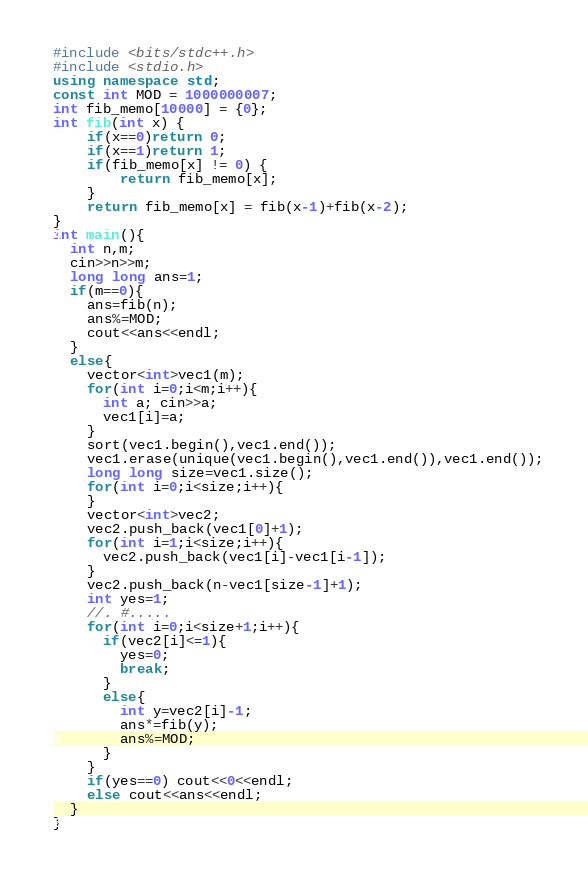<code> <loc_0><loc_0><loc_500><loc_500><_C++_>#include <bits/stdc++.h>
#include <stdio.h>
using namespace std;
const int MOD = 1000000007;
int fib_memo[10000] = {0};
int fib(int x) {
    if(x==0)return 0;
    if(x==1)return 1;
    if(fib_memo[x] != 0) {
        return fib_memo[x];
    }
    return fib_memo[x] = fib(x-1)+fib(x-2);
}
int main(){
  int n,m;  
  cin>>n>>m;
  long long ans=1;
  if(m==0){
    ans=fib(n);
    ans%=MOD;
    cout<<ans<<endl;
  }
  else{
    vector<int>vec1(m);
    for(int i=0;i<m;i++){
      int a; cin>>a;
      vec1[i]=a;
    }
    sort(vec1.begin(),vec1.end());
    vec1.erase(unique(vec1.begin(),vec1.end()),vec1.end());
    long long size=vec1.size();
    for(int i=0;i<size;i++){
    }
    vector<int>vec2;
    vec2.push_back(vec1[0]+1);
    for(int i=1;i<size;i++){
      vec2.push_back(vec1[i]-vec1[i-1]);
    }
    vec2.push_back(n-vec1[size-1]+1);
    int yes=1;
    //. #.....
    for(int i=0;i<size+1;i++){
      if(vec2[i]<=1){
        yes=0;
        break;
      }
      else{
        int y=vec2[i]-1;
        ans*=fib(y);
        ans%=MOD;
      }
    }
    if(yes==0) cout<<0<<endl;
    else cout<<ans<<endl;
  }
}</code> 